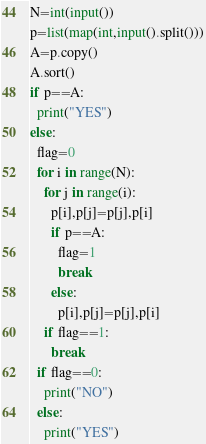Convert code to text. <code><loc_0><loc_0><loc_500><loc_500><_Python_>N=int(input())
p=list(map(int,input().split()))
A=p.copy()
A.sort()
if p==A:
  print("YES")
else:
  flag=0
  for i in range(N):
    for j in range(i):
      p[i],p[j]=p[j],p[i]
      if p==A:
        flag=1
        break
      else:
        p[i],p[j]=p[j],p[i]
    if flag==1:
      break
  if flag==0:
    print("NO")
  else:
    print("YES")</code> 